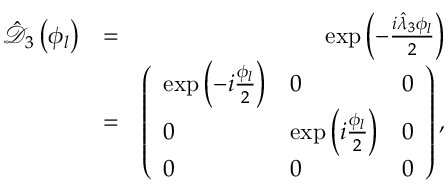Convert formula to latex. <formula><loc_0><loc_0><loc_500><loc_500>\begin{array} { r l r } { \hat { \mathcal { D } } _ { 3 } \left ( \phi _ { l } \right ) } & { = } & { \exp \left ( - \frac { i \hat { \lambda } _ { 3 } \phi _ { l } } { 2 } \right ) } \\ & { = } & { \left ( \begin{array} { l l l } { \exp \left ( - i \frac { \phi _ { l } } { 2 } \right ) } & { 0 } & { 0 } \\ { 0 } & { \exp \left ( i \frac { \phi _ { l } } { 2 } \right ) } & { 0 } \\ { 0 } & { 0 } & { 0 } \end{array} \right ) , } \end{array}</formula> 